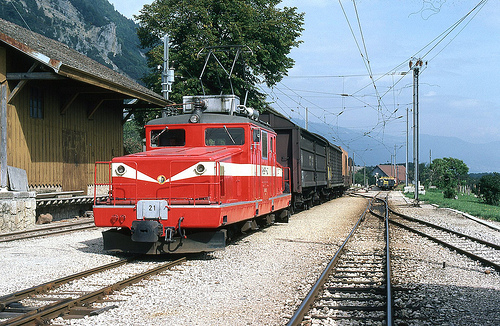What kind of vehicle is red? The red vehicle depicted is a locomotive, prominently positioned in the image. 